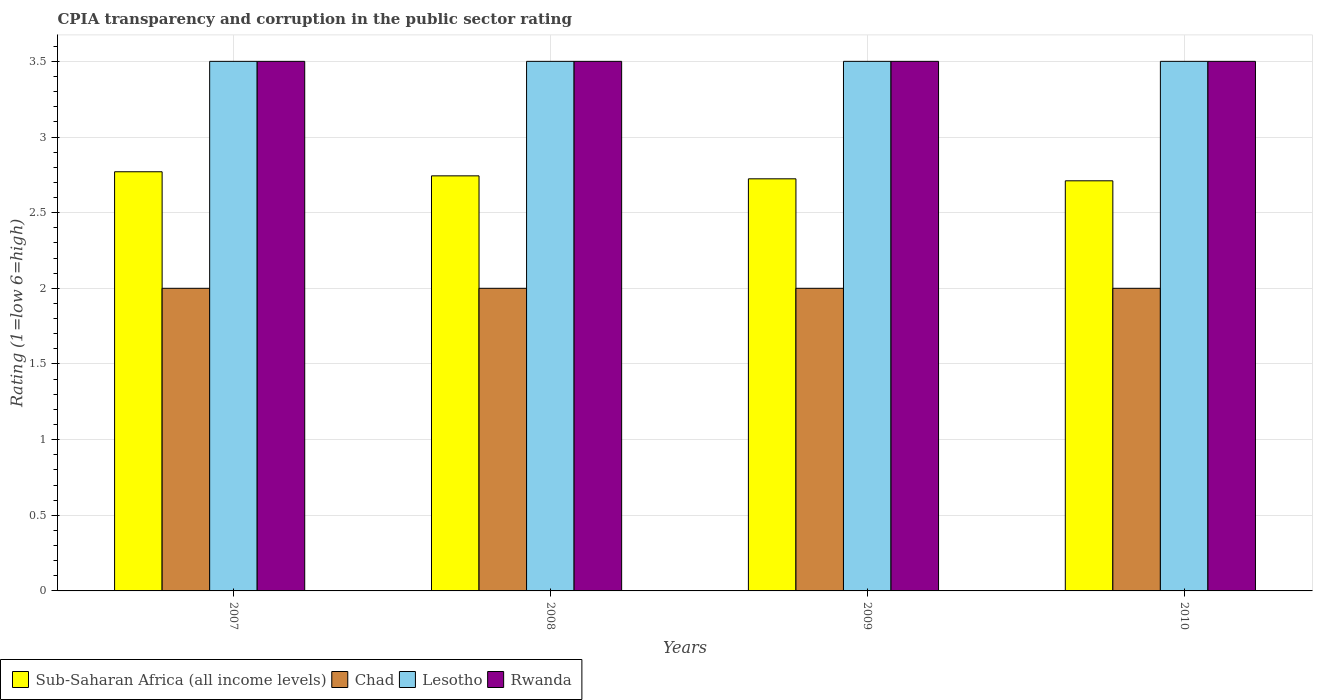How many different coloured bars are there?
Your response must be concise. 4. Are the number of bars per tick equal to the number of legend labels?
Offer a terse response. Yes. Are the number of bars on each tick of the X-axis equal?
Ensure brevity in your answer.  Yes. How many bars are there on the 3rd tick from the left?
Your answer should be compact. 4. What is the label of the 4th group of bars from the left?
Make the answer very short. 2010. In how many cases, is the number of bars for a given year not equal to the number of legend labels?
Ensure brevity in your answer.  0. What is the CPIA rating in Lesotho in 2007?
Give a very brief answer. 3.5. In which year was the CPIA rating in Lesotho maximum?
Give a very brief answer. 2007. In which year was the CPIA rating in Sub-Saharan Africa (all income levels) minimum?
Keep it short and to the point. 2010. What is the difference between the CPIA rating in Lesotho in 2008 and the CPIA rating in Chad in 2010?
Offer a very short reply. 1.5. What is the average CPIA rating in Sub-Saharan Africa (all income levels) per year?
Your response must be concise. 2.74. In the year 2007, what is the difference between the CPIA rating in Sub-Saharan Africa (all income levels) and CPIA rating in Lesotho?
Offer a very short reply. -0.73. In how many years, is the CPIA rating in Lesotho greater than 3?
Give a very brief answer. 4. What is the ratio of the CPIA rating in Sub-Saharan Africa (all income levels) in 2008 to that in 2010?
Give a very brief answer. 1.01. What is the difference between the highest and the lowest CPIA rating in Sub-Saharan Africa (all income levels)?
Give a very brief answer. 0.06. In how many years, is the CPIA rating in Lesotho greater than the average CPIA rating in Lesotho taken over all years?
Make the answer very short. 0. Is it the case that in every year, the sum of the CPIA rating in Lesotho and CPIA rating in Chad is greater than the sum of CPIA rating in Sub-Saharan Africa (all income levels) and CPIA rating in Rwanda?
Keep it short and to the point. No. What does the 1st bar from the left in 2007 represents?
Make the answer very short. Sub-Saharan Africa (all income levels). What does the 3rd bar from the right in 2010 represents?
Your response must be concise. Chad. How many bars are there?
Offer a very short reply. 16. Are all the bars in the graph horizontal?
Your response must be concise. No. Are the values on the major ticks of Y-axis written in scientific E-notation?
Your response must be concise. No. Does the graph contain any zero values?
Offer a terse response. No. Does the graph contain grids?
Keep it short and to the point. Yes. Where does the legend appear in the graph?
Your answer should be very brief. Bottom left. What is the title of the graph?
Offer a terse response. CPIA transparency and corruption in the public sector rating. What is the label or title of the X-axis?
Offer a terse response. Years. What is the label or title of the Y-axis?
Give a very brief answer. Rating (1=low 6=high). What is the Rating (1=low 6=high) in Sub-Saharan Africa (all income levels) in 2007?
Ensure brevity in your answer.  2.77. What is the Rating (1=low 6=high) in Rwanda in 2007?
Provide a short and direct response. 3.5. What is the Rating (1=low 6=high) of Sub-Saharan Africa (all income levels) in 2008?
Provide a succinct answer. 2.74. What is the Rating (1=low 6=high) of Lesotho in 2008?
Provide a short and direct response. 3.5. What is the Rating (1=low 6=high) of Rwanda in 2008?
Your answer should be very brief. 3.5. What is the Rating (1=low 6=high) in Sub-Saharan Africa (all income levels) in 2009?
Provide a short and direct response. 2.72. What is the Rating (1=low 6=high) of Rwanda in 2009?
Give a very brief answer. 3.5. What is the Rating (1=low 6=high) in Sub-Saharan Africa (all income levels) in 2010?
Provide a short and direct response. 2.71. What is the Rating (1=low 6=high) of Lesotho in 2010?
Make the answer very short. 3.5. What is the Rating (1=low 6=high) in Rwanda in 2010?
Offer a terse response. 3.5. Across all years, what is the maximum Rating (1=low 6=high) in Sub-Saharan Africa (all income levels)?
Offer a very short reply. 2.77. Across all years, what is the maximum Rating (1=low 6=high) of Chad?
Offer a very short reply. 2. Across all years, what is the minimum Rating (1=low 6=high) of Sub-Saharan Africa (all income levels)?
Your answer should be very brief. 2.71. Across all years, what is the minimum Rating (1=low 6=high) in Chad?
Offer a very short reply. 2. What is the total Rating (1=low 6=high) of Sub-Saharan Africa (all income levels) in the graph?
Give a very brief answer. 10.95. What is the difference between the Rating (1=low 6=high) of Sub-Saharan Africa (all income levels) in 2007 and that in 2008?
Provide a succinct answer. 0.03. What is the difference between the Rating (1=low 6=high) in Chad in 2007 and that in 2008?
Make the answer very short. 0. What is the difference between the Rating (1=low 6=high) of Sub-Saharan Africa (all income levels) in 2007 and that in 2009?
Give a very brief answer. 0.05. What is the difference between the Rating (1=low 6=high) in Chad in 2007 and that in 2009?
Your answer should be compact. 0. What is the difference between the Rating (1=low 6=high) of Lesotho in 2007 and that in 2009?
Your response must be concise. 0. What is the difference between the Rating (1=low 6=high) in Sub-Saharan Africa (all income levels) in 2007 and that in 2010?
Ensure brevity in your answer.  0.06. What is the difference between the Rating (1=low 6=high) of Chad in 2007 and that in 2010?
Your response must be concise. 0. What is the difference between the Rating (1=low 6=high) of Lesotho in 2007 and that in 2010?
Ensure brevity in your answer.  0. What is the difference between the Rating (1=low 6=high) in Sub-Saharan Africa (all income levels) in 2008 and that in 2009?
Make the answer very short. 0.02. What is the difference between the Rating (1=low 6=high) in Sub-Saharan Africa (all income levels) in 2008 and that in 2010?
Your response must be concise. 0.03. What is the difference between the Rating (1=low 6=high) in Lesotho in 2008 and that in 2010?
Ensure brevity in your answer.  0. What is the difference between the Rating (1=low 6=high) of Rwanda in 2008 and that in 2010?
Provide a succinct answer. 0. What is the difference between the Rating (1=low 6=high) in Sub-Saharan Africa (all income levels) in 2009 and that in 2010?
Your response must be concise. 0.01. What is the difference between the Rating (1=low 6=high) in Chad in 2009 and that in 2010?
Make the answer very short. 0. What is the difference between the Rating (1=low 6=high) of Rwanda in 2009 and that in 2010?
Offer a terse response. 0. What is the difference between the Rating (1=low 6=high) in Sub-Saharan Africa (all income levels) in 2007 and the Rating (1=low 6=high) in Chad in 2008?
Provide a succinct answer. 0.77. What is the difference between the Rating (1=low 6=high) of Sub-Saharan Africa (all income levels) in 2007 and the Rating (1=low 6=high) of Lesotho in 2008?
Your answer should be compact. -0.73. What is the difference between the Rating (1=low 6=high) of Sub-Saharan Africa (all income levels) in 2007 and the Rating (1=low 6=high) of Rwanda in 2008?
Give a very brief answer. -0.73. What is the difference between the Rating (1=low 6=high) in Chad in 2007 and the Rating (1=low 6=high) in Lesotho in 2008?
Provide a succinct answer. -1.5. What is the difference between the Rating (1=low 6=high) in Chad in 2007 and the Rating (1=low 6=high) in Rwanda in 2008?
Your response must be concise. -1.5. What is the difference between the Rating (1=low 6=high) in Sub-Saharan Africa (all income levels) in 2007 and the Rating (1=low 6=high) in Chad in 2009?
Ensure brevity in your answer.  0.77. What is the difference between the Rating (1=low 6=high) of Sub-Saharan Africa (all income levels) in 2007 and the Rating (1=low 6=high) of Lesotho in 2009?
Ensure brevity in your answer.  -0.73. What is the difference between the Rating (1=low 6=high) in Sub-Saharan Africa (all income levels) in 2007 and the Rating (1=low 6=high) in Rwanda in 2009?
Your answer should be compact. -0.73. What is the difference between the Rating (1=low 6=high) in Chad in 2007 and the Rating (1=low 6=high) in Lesotho in 2009?
Make the answer very short. -1.5. What is the difference between the Rating (1=low 6=high) of Chad in 2007 and the Rating (1=low 6=high) of Rwanda in 2009?
Give a very brief answer. -1.5. What is the difference between the Rating (1=low 6=high) in Lesotho in 2007 and the Rating (1=low 6=high) in Rwanda in 2009?
Provide a short and direct response. 0. What is the difference between the Rating (1=low 6=high) of Sub-Saharan Africa (all income levels) in 2007 and the Rating (1=low 6=high) of Chad in 2010?
Make the answer very short. 0.77. What is the difference between the Rating (1=low 6=high) in Sub-Saharan Africa (all income levels) in 2007 and the Rating (1=low 6=high) in Lesotho in 2010?
Provide a succinct answer. -0.73. What is the difference between the Rating (1=low 6=high) in Sub-Saharan Africa (all income levels) in 2007 and the Rating (1=low 6=high) in Rwanda in 2010?
Give a very brief answer. -0.73. What is the difference between the Rating (1=low 6=high) of Sub-Saharan Africa (all income levels) in 2008 and the Rating (1=low 6=high) of Chad in 2009?
Your answer should be compact. 0.74. What is the difference between the Rating (1=low 6=high) in Sub-Saharan Africa (all income levels) in 2008 and the Rating (1=low 6=high) in Lesotho in 2009?
Offer a very short reply. -0.76. What is the difference between the Rating (1=low 6=high) of Sub-Saharan Africa (all income levels) in 2008 and the Rating (1=low 6=high) of Rwanda in 2009?
Keep it short and to the point. -0.76. What is the difference between the Rating (1=low 6=high) in Chad in 2008 and the Rating (1=low 6=high) in Lesotho in 2009?
Provide a succinct answer. -1.5. What is the difference between the Rating (1=low 6=high) of Sub-Saharan Africa (all income levels) in 2008 and the Rating (1=low 6=high) of Chad in 2010?
Offer a very short reply. 0.74. What is the difference between the Rating (1=low 6=high) of Sub-Saharan Africa (all income levels) in 2008 and the Rating (1=low 6=high) of Lesotho in 2010?
Your response must be concise. -0.76. What is the difference between the Rating (1=low 6=high) of Sub-Saharan Africa (all income levels) in 2008 and the Rating (1=low 6=high) of Rwanda in 2010?
Give a very brief answer. -0.76. What is the difference between the Rating (1=low 6=high) in Chad in 2008 and the Rating (1=low 6=high) in Lesotho in 2010?
Make the answer very short. -1.5. What is the difference between the Rating (1=low 6=high) in Chad in 2008 and the Rating (1=low 6=high) in Rwanda in 2010?
Make the answer very short. -1.5. What is the difference between the Rating (1=low 6=high) of Lesotho in 2008 and the Rating (1=low 6=high) of Rwanda in 2010?
Provide a succinct answer. 0. What is the difference between the Rating (1=low 6=high) of Sub-Saharan Africa (all income levels) in 2009 and the Rating (1=low 6=high) of Chad in 2010?
Make the answer very short. 0.72. What is the difference between the Rating (1=low 6=high) in Sub-Saharan Africa (all income levels) in 2009 and the Rating (1=low 6=high) in Lesotho in 2010?
Ensure brevity in your answer.  -0.78. What is the difference between the Rating (1=low 6=high) of Sub-Saharan Africa (all income levels) in 2009 and the Rating (1=low 6=high) of Rwanda in 2010?
Offer a terse response. -0.78. What is the average Rating (1=low 6=high) of Sub-Saharan Africa (all income levels) per year?
Ensure brevity in your answer.  2.74. What is the average Rating (1=low 6=high) of Chad per year?
Your response must be concise. 2. What is the average Rating (1=low 6=high) of Rwanda per year?
Provide a succinct answer. 3.5. In the year 2007, what is the difference between the Rating (1=low 6=high) in Sub-Saharan Africa (all income levels) and Rating (1=low 6=high) in Chad?
Keep it short and to the point. 0.77. In the year 2007, what is the difference between the Rating (1=low 6=high) in Sub-Saharan Africa (all income levels) and Rating (1=low 6=high) in Lesotho?
Make the answer very short. -0.73. In the year 2007, what is the difference between the Rating (1=low 6=high) in Sub-Saharan Africa (all income levels) and Rating (1=low 6=high) in Rwanda?
Keep it short and to the point. -0.73. In the year 2007, what is the difference between the Rating (1=low 6=high) of Chad and Rating (1=low 6=high) of Lesotho?
Give a very brief answer. -1.5. In the year 2007, what is the difference between the Rating (1=low 6=high) of Chad and Rating (1=low 6=high) of Rwanda?
Your answer should be very brief. -1.5. In the year 2007, what is the difference between the Rating (1=low 6=high) of Lesotho and Rating (1=low 6=high) of Rwanda?
Your answer should be compact. 0. In the year 2008, what is the difference between the Rating (1=low 6=high) in Sub-Saharan Africa (all income levels) and Rating (1=low 6=high) in Chad?
Offer a very short reply. 0.74. In the year 2008, what is the difference between the Rating (1=low 6=high) in Sub-Saharan Africa (all income levels) and Rating (1=low 6=high) in Lesotho?
Offer a terse response. -0.76. In the year 2008, what is the difference between the Rating (1=low 6=high) in Sub-Saharan Africa (all income levels) and Rating (1=low 6=high) in Rwanda?
Your answer should be compact. -0.76. In the year 2008, what is the difference between the Rating (1=low 6=high) of Lesotho and Rating (1=low 6=high) of Rwanda?
Your answer should be very brief. 0. In the year 2009, what is the difference between the Rating (1=low 6=high) of Sub-Saharan Africa (all income levels) and Rating (1=low 6=high) of Chad?
Offer a terse response. 0.72. In the year 2009, what is the difference between the Rating (1=low 6=high) in Sub-Saharan Africa (all income levels) and Rating (1=low 6=high) in Lesotho?
Provide a short and direct response. -0.78. In the year 2009, what is the difference between the Rating (1=low 6=high) of Sub-Saharan Africa (all income levels) and Rating (1=low 6=high) of Rwanda?
Ensure brevity in your answer.  -0.78. In the year 2009, what is the difference between the Rating (1=low 6=high) of Chad and Rating (1=low 6=high) of Lesotho?
Offer a very short reply. -1.5. In the year 2010, what is the difference between the Rating (1=low 6=high) of Sub-Saharan Africa (all income levels) and Rating (1=low 6=high) of Chad?
Your answer should be very brief. 0.71. In the year 2010, what is the difference between the Rating (1=low 6=high) of Sub-Saharan Africa (all income levels) and Rating (1=low 6=high) of Lesotho?
Offer a terse response. -0.79. In the year 2010, what is the difference between the Rating (1=low 6=high) of Sub-Saharan Africa (all income levels) and Rating (1=low 6=high) of Rwanda?
Offer a very short reply. -0.79. In the year 2010, what is the difference between the Rating (1=low 6=high) of Chad and Rating (1=low 6=high) of Rwanda?
Provide a short and direct response. -1.5. What is the ratio of the Rating (1=low 6=high) of Sub-Saharan Africa (all income levels) in 2007 to that in 2008?
Make the answer very short. 1.01. What is the ratio of the Rating (1=low 6=high) in Lesotho in 2007 to that in 2008?
Keep it short and to the point. 1. What is the ratio of the Rating (1=low 6=high) in Rwanda in 2007 to that in 2008?
Your response must be concise. 1. What is the ratio of the Rating (1=low 6=high) in Sub-Saharan Africa (all income levels) in 2007 to that in 2009?
Your answer should be compact. 1.02. What is the ratio of the Rating (1=low 6=high) of Lesotho in 2007 to that in 2009?
Your answer should be very brief. 1. What is the ratio of the Rating (1=low 6=high) of Rwanda in 2007 to that in 2009?
Your response must be concise. 1. What is the ratio of the Rating (1=low 6=high) of Chad in 2007 to that in 2010?
Offer a very short reply. 1. What is the ratio of the Rating (1=low 6=high) of Lesotho in 2007 to that in 2010?
Your response must be concise. 1. What is the ratio of the Rating (1=low 6=high) in Rwanda in 2007 to that in 2010?
Keep it short and to the point. 1. What is the ratio of the Rating (1=low 6=high) in Sub-Saharan Africa (all income levels) in 2008 to that in 2009?
Your answer should be compact. 1.01. What is the ratio of the Rating (1=low 6=high) of Rwanda in 2008 to that in 2009?
Make the answer very short. 1. What is the ratio of the Rating (1=low 6=high) in Sub-Saharan Africa (all income levels) in 2008 to that in 2010?
Offer a terse response. 1.01. What is the ratio of the Rating (1=low 6=high) in Chad in 2008 to that in 2010?
Ensure brevity in your answer.  1. What is the ratio of the Rating (1=low 6=high) in Rwanda in 2008 to that in 2010?
Make the answer very short. 1. What is the ratio of the Rating (1=low 6=high) in Sub-Saharan Africa (all income levels) in 2009 to that in 2010?
Give a very brief answer. 1. What is the ratio of the Rating (1=low 6=high) in Rwanda in 2009 to that in 2010?
Provide a short and direct response. 1. What is the difference between the highest and the second highest Rating (1=low 6=high) in Sub-Saharan Africa (all income levels)?
Offer a terse response. 0.03. What is the difference between the highest and the second highest Rating (1=low 6=high) of Chad?
Your answer should be very brief. 0. What is the difference between the highest and the second highest Rating (1=low 6=high) of Rwanda?
Your answer should be compact. 0. What is the difference between the highest and the lowest Rating (1=low 6=high) of Sub-Saharan Africa (all income levels)?
Your response must be concise. 0.06. 